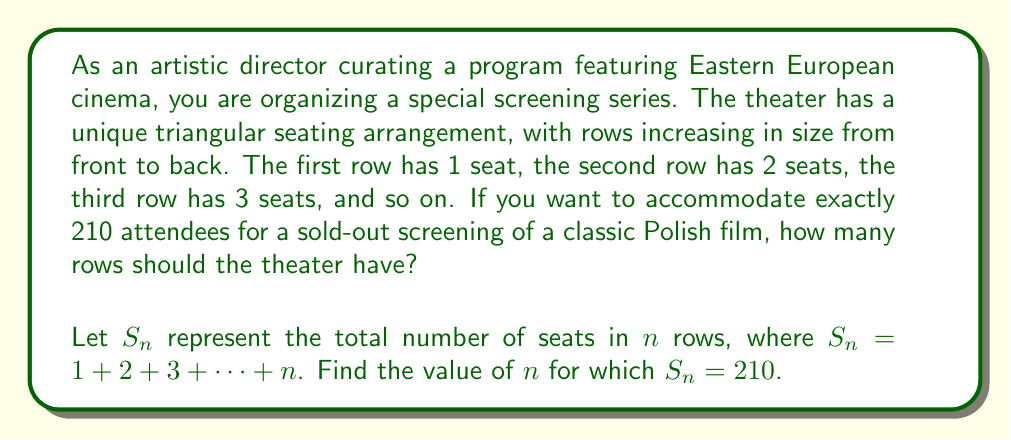Can you solve this math problem? To solve this problem, we need to use the formula for the sum of an arithmetic sequence:

$S_n = \frac{n(a_1 + a_n)}{2}$

Where:
$S_n$ is the sum of the sequence (total number of seats)
$n$ is the number of terms (number of rows)
$a_1$ is the first term (1 seat in the first row)
$a_n$ is the last term (n seats in the last row)

We know that $S_n = 210$, $a_1 = 1$, and $a_n = n$. Substituting these into the formula:

$210 = \frac{n(1 + n)}{2}$

Multiplying both sides by 2:

$420 = n(1 + n) = n + n^2$

Rearranging the equation:

$n^2 + n - 420 = 0$

This is a quadratic equation. We can solve it using the quadratic formula:

$n = \frac{-b \pm \sqrt{b^2 - 4ac}}{2a}$

Where $a = 1$, $b = 1$, and $c = -420$

$n = \frac{-1 \pm \sqrt{1^2 - 4(1)(-420)}}{2(1)}$

$n = \frac{-1 \pm \sqrt{1681}}{2}$

$n = \frac{-1 \pm 41}{2}$

This gives us two solutions: $n = 20$ or $n = -21$

Since the number of rows cannot be negative, we take the positive solution:

$n = 20$

To verify:
$S_{20} = 1 + 2 + 3 + ... + 20 = \frac{20(1 + 20)}{2} = 210$

Therefore, the theater should have 20 rows to accommodate exactly 210 attendees.
Answer: The theater should have 20 rows to accommodate exactly 210 attendees for the screening of the classic Polish film. 